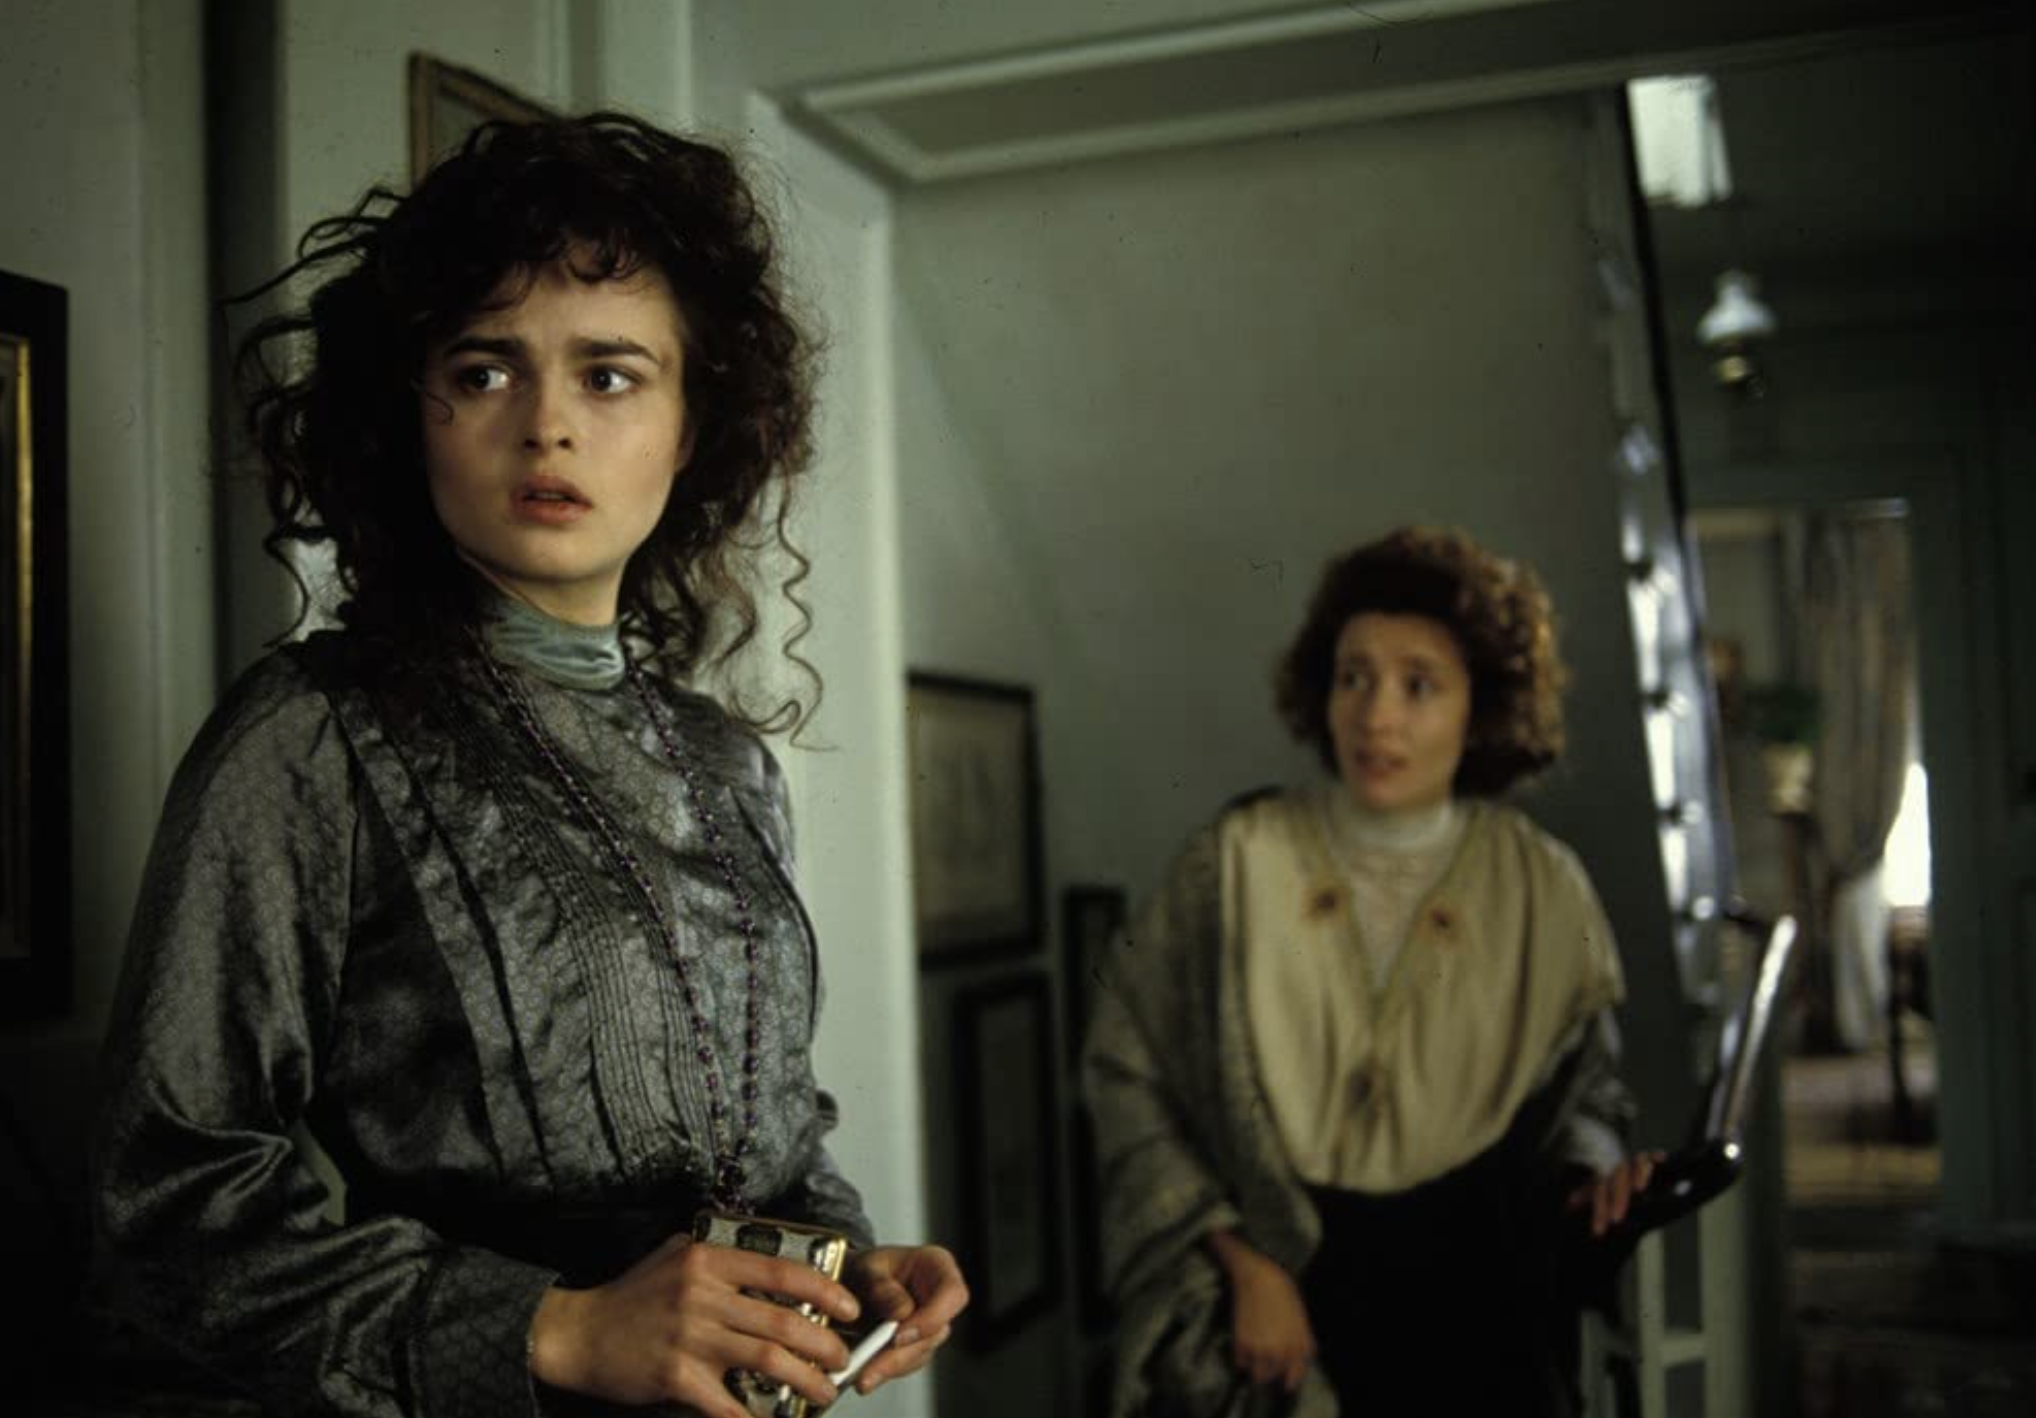Based on their attire, what era is likely being depicted in this image? The attire of the characters, particularly the high-necked dress with intricate details worn by Lucy and the formal coat and parasol held by Charlotte, suggests that this scene is set in the early 20th century, around the Edwardian era. This aligns well with the novel 'A Room with a View', which is set in the early 1900s. What secret message might be hidden in the patterns on Lucy's dress, if you were to imagine the fabric telling a story? If we were to imagine a secret message woven into the patterns on Lucy's dress, it might tell a story of her inner life and struggles. The intricate detailing and flowing patterns could represent the complexity of her thoughts and emotions—each swirl and curve a twist of fate or a moment of introspection. The fabric could symbolize the path she must navigate through societal expectations and personal desires, weaving a tale of love, struggle, and eventual self-discovery. 